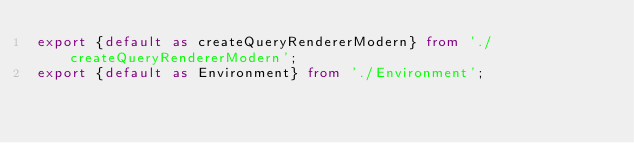<code> <loc_0><loc_0><loc_500><loc_500><_TypeScript_>export {default as createQueryRendererModern} from './createQueryRendererModern';
export {default as Environment} from './Environment';
</code> 